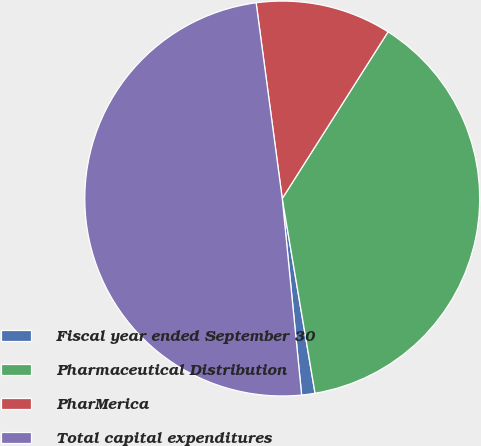Convert chart to OTSL. <chart><loc_0><loc_0><loc_500><loc_500><pie_chart><fcel>Fiscal year ended September 30<fcel>Pharmaceutical Distribution<fcel>PharMerica<fcel>Total capital expenditures<nl><fcel>1.09%<fcel>38.34%<fcel>11.11%<fcel>49.45%<nl></chart> 